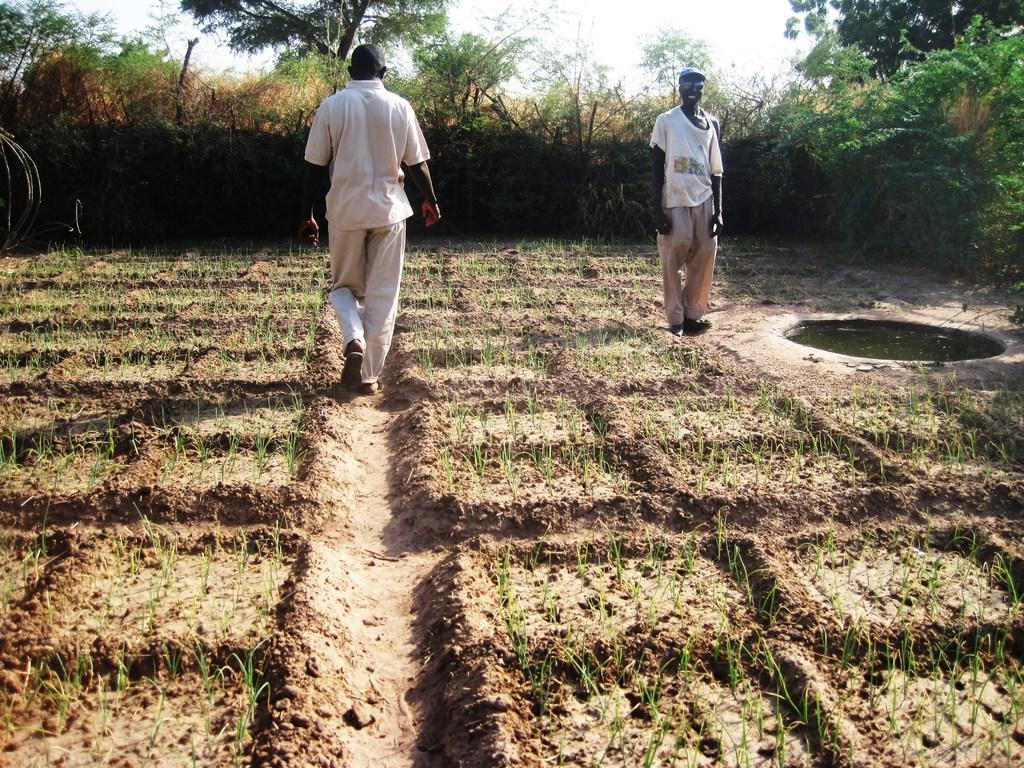Please provide a concise description of this image. In this image we can see two persons, there are some crops, plants, trees, water, also we can see the sky. 